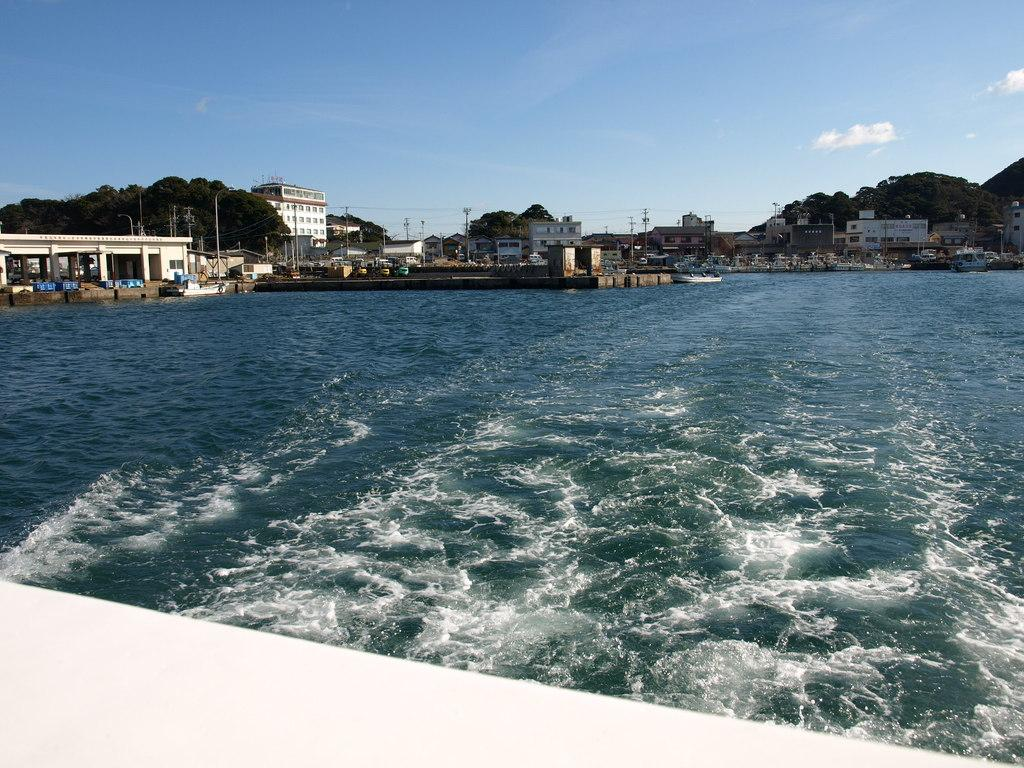What is the primary element visible in the image? There is water in the image. What can be seen in the background of the image? There are buildings, trees, light-poles, and current poles in the background of the image. What type of natural feature is visible in the image? There are mountains visible in the image. What is the color of the sky in the image? The sky is blue and white in color. Can you describe the woman's legs in the image? There is no woman present in the image, so it is not possible to describe her legs. 